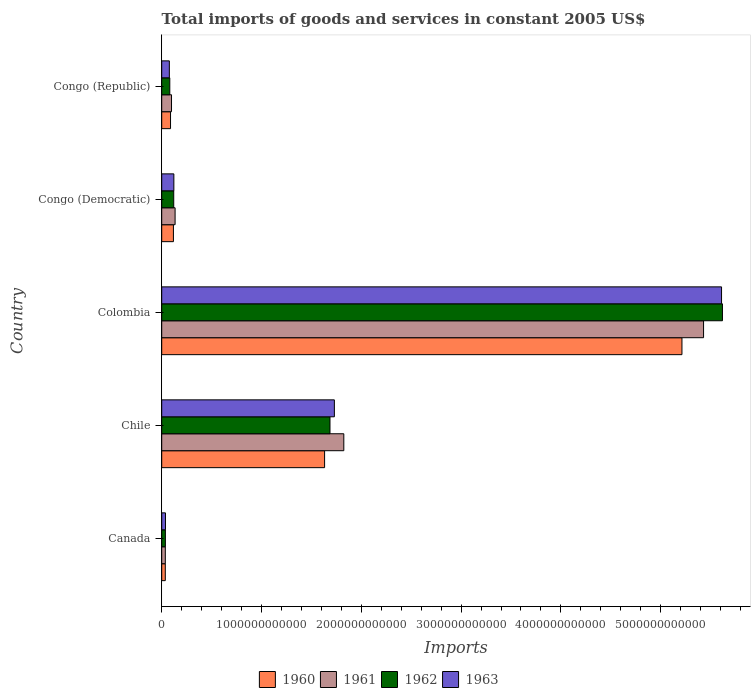How many groups of bars are there?
Keep it short and to the point. 5. How many bars are there on the 1st tick from the top?
Offer a terse response. 4. What is the label of the 4th group of bars from the top?
Keep it short and to the point. Chile. What is the total imports of goods and services in 1962 in Congo (Republic)?
Your answer should be compact. 8.10e+1. Across all countries, what is the maximum total imports of goods and services in 1963?
Provide a short and direct response. 5.61e+12. Across all countries, what is the minimum total imports of goods and services in 1962?
Give a very brief answer. 3.69e+1. In which country was the total imports of goods and services in 1963 minimum?
Ensure brevity in your answer.  Canada. What is the total total imports of goods and services in 1962 in the graph?
Offer a terse response. 7.54e+12. What is the difference between the total imports of goods and services in 1963 in Canada and that in Congo (Democratic)?
Provide a succinct answer. -8.39e+1. What is the difference between the total imports of goods and services in 1961 in Chile and the total imports of goods and services in 1962 in Congo (Republic)?
Provide a short and direct response. 1.74e+12. What is the average total imports of goods and services in 1963 per country?
Your response must be concise. 1.52e+12. What is the difference between the total imports of goods and services in 1961 and total imports of goods and services in 1963 in Congo (Republic)?
Offer a terse response. 2.18e+1. What is the ratio of the total imports of goods and services in 1962 in Colombia to that in Congo (Democratic)?
Ensure brevity in your answer.  46.63. Is the total imports of goods and services in 1963 in Canada less than that in Congo (Republic)?
Provide a succinct answer. Yes. What is the difference between the highest and the second highest total imports of goods and services in 1963?
Your answer should be very brief. 3.88e+12. What is the difference between the highest and the lowest total imports of goods and services in 1962?
Offer a terse response. 5.58e+12. What does the 4th bar from the top in Chile represents?
Your answer should be compact. 1960. What does the 4th bar from the bottom in Colombia represents?
Give a very brief answer. 1963. Is it the case that in every country, the sum of the total imports of goods and services in 1963 and total imports of goods and services in 1962 is greater than the total imports of goods and services in 1961?
Ensure brevity in your answer.  Yes. How many bars are there?
Provide a short and direct response. 20. What is the difference between two consecutive major ticks on the X-axis?
Offer a very short reply. 1.00e+12. Are the values on the major ticks of X-axis written in scientific E-notation?
Keep it short and to the point. No. Does the graph contain any zero values?
Offer a very short reply. No. Where does the legend appear in the graph?
Provide a succinct answer. Bottom center. What is the title of the graph?
Give a very brief answer. Total imports of goods and services in constant 2005 US$. What is the label or title of the X-axis?
Ensure brevity in your answer.  Imports. What is the label or title of the Y-axis?
Make the answer very short. Country. What is the Imports in 1960 in Canada?
Offer a very short reply. 3.60e+1. What is the Imports in 1961 in Canada?
Your response must be concise. 3.61e+1. What is the Imports in 1962 in Canada?
Your response must be concise. 3.69e+1. What is the Imports of 1963 in Canada?
Your response must be concise. 3.79e+1. What is the Imports of 1960 in Chile?
Offer a terse response. 1.63e+12. What is the Imports in 1961 in Chile?
Provide a short and direct response. 1.82e+12. What is the Imports in 1962 in Chile?
Keep it short and to the point. 1.69e+12. What is the Imports of 1963 in Chile?
Give a very brief answer. 1.73e+12. What is the Imports in 1960 in Colombia?
Your answer should be compact. 5.21e+12. What is the Imports in 1961 in Colombia?
Keep it short and to the point. 5.43e+12. What is the Imports in 1962 in Colombia?
Your answer should be compact. 5.62e+12. What is the Imports of 1963 in Colombia?
Keep it short and to the point. 5.61e+12. What is the Imports of 1960 in Congo (Democratic)?
Your answer should be very brief. 1.17e+11. What is the Imports in 1961 in Congo (Democratic)?
Your answer should be very brief. 1.34e+11. What is the Imports in 1962 in Congo (Democratic)?
Provide a succinct answer. 1.20e+11. What is the Imports in 1963 in Congo (Democratic)?
Offer a terse response. 1.22e+11. What is the Imports in 1960 in Congo (Republic)?
Make the answer very short. 8.83e+1. What is the Imports of 1961 in Congo (Republic)?
Provide a short and direct response. 9.83e+1. What is the Imports of 1962 in Congo (Republic)?
Your answer should be very brief. 8.10e+1. What is the Imports in 1963 in Congo (Republic)?
Offer a terse response. 7.65e+1. Across all countries, what is the maximum Imports of 1960?
Provide a succinct answer. 5.21e+12. Across all countries, what is the maximum Imports in 1961?
Offer a terse response. 5.43e+12. Across all countries, what is the maximum Imports in 1962?
Give a very brief answer. 5.62e+12. Across all countries, what is the maximum Imports of 1963?
Keep it short and to the point. 5.61e+12. Across all countries, what is the minimum Imports in 1960?
Keep it short and to the point. 3.60e+1. Across all countries, what is the minimum Imports in 1961?
Offer a very short reply. 3.61e+1. Across all countries, what is the minimum Imports in 1962?
Offer a terse response. 3.69e+1. Across all countries, what is the minimum Imports of 1963?
Provide a succinct answer. 3.79e+1. What is the total Imports of 1960 in the graph?
Make the answer very short. 7.09e+12. What is the total Imports in 1961 in the graph?
Provide a short and direct response. 7.52e+12. What is the total Imports in 1962 in the graph?
Make the answer very short. 7.54e+12. What is the total Imports in 1963 in the graph?
Keep it short and to the point. 7.58e+12. What is the difference between the Imports of 1960 in Canada and that in Chile?
Keep it short and to the point. -1.60e+12. What is the difference between the Imports in 1961 in Canada and that in Chile?
Give a very brief answer. -1.79e+12. What is the difference between the Imports of 1962 in Canada and that in Chile?
Offer a very short reply. -1.65e+12. What is the difference between the Imports in 1963 in Canada and that in Chile?
Provide a short and direct response. -1.69e+12. What is the difference between the Imports of 1960 in Canada and that in Colombia?
Give a very brief answer. -5.18e+12. What is the difference between the Imports of 1961 in Canada and that in Colombia?
Make the answer very short. -5.39e+12. What is the difference between the Imports of 1962 in Canada and that in Colombia?
Provide a short and direct response. -5.58e+12. What is the difference between the Imports of 1963 in Canada and that in Colombia?
Provide a short and direct response. -5.57e+12. What is the difference between the Imports in 1960 in Canada and that in Congo (Democratic)?
Provide a succinct answer. -8.14e+1. What is the difference between the Imports in 1961 in Canada and that in Congo (Democratic)?
Your answer should be very brief. -9.81e+1. What is the difference between the Imports of 1962 in Canada and that in Congo (Democratic)?
Offer a terse response. -8.36e+1. What is the difference between the Imports in 1963 in Canada and that in Congo (Democratic)?
Your response must be concise. -8.39e+1. What is the difference between the Imports in 1960 in Canada and that in Congo (Republic)?
Make the answer very short. -5.24e+1. What is the difference between the Imports in 1961 in Canada and that in Congo (Republic)?
Ensure brevity in your answer.  -6.22e+1. What is the difference between the Imports in 1962 in Canada and that in Congo (Republic)?
Give a very brief answer. -4.41e+1. What is the difference between the Imports in 1963 in Canada and that in Congo (Republic)?
Your answer should be compact. -3.86e+1. What is the difference between the Imports of 1960 in Chile and that in Colombia?
Ensure brevity in your answer.  -3.58e+12. What is the difference between the Imports of 1961 in Chile and that in Colombia?
Provide a succinct answer. -3.61e+12. What is the difference between the Imports in 1962 in Chile and that in Colombia?
Provide a short and direct response. -3.93e+12. What is the difference between the Imports in 1963 in Chile and that in Colombia?
Make the answer very short. -3.88e+12. What is the difference between the Imports in 1960 in Chile and that in Congo (Democratic)?
Your response must be concise. 1.51e+12. What is the difference between the Imports of 1961 in Chile and that in Congo (Democratic)?
Give a very brief answer. 1.69e+12. What is the difference between the Imports in 1962 in Chile and that in Congo (Democratic)?
Your response must be concise. 1.57e+12. What is the difference between the Imports in 1963 in Chile and that in Congo (Democratic)?
Offer a very short reply. 1.61e+12. What is the difference between the Imports of 1960 in Chile and that in Congo (Republic)?
Keep it short and to the point. 1.54e+12. What is the difference between the Imports of 1961 in Chile and that in Congo (Republic)?
Provide a short and direct response. 1.73e+12. What is the difference between the Imports in 1962 in Chile and that in Congo (Republic)?
Keep it short and to the point. 1.61e+12. What is the difference between the Imports of 1963 in Chile and that in Congo (Republic)?
Your response must be concise. 1.65e+12. What is the difference between the Imports in 1960 in Colombia and that in Congo (Democratic)?
Your answer should be compact. 5.10e+12. What is the difference between the Imports of 1961 in Colombia and that in Congo (Democratic)?
Provide a short and direct response. 5.30e+12. What is the difference between the Imports in 1962 in Colombia and that in Congo (Democratic)?
Keep it short and to the point. 5.50e+12. What is the difference between the Imports of 1963 in Colombia and that in Congo (Democratic)?
Ensure brevity in your answer.  5.49e+12. What is the difference between the Imports in 1960 in Colombia and that in Congo (Republic)?
Your answer should be compact. 5.13e+12. What is the difference between the Imports of 1961 in Colombia and that in Congo (Republic)?
Your answer should be compact. 5.33e+12. What is the difference between the Imports in 1962 in Colombia and that in Congo (Republic)?
Your response must be concise. 5.54e+12. What is the difference between the Imports of 1963 in Colombia and that in Congo (Republic)?
Provide a short and direct response. 5.53e+12. What is the difference between the Imports of 1960 in Congo (Democratic) and that in Congo (Republic)?
Give a very brief answer. 2.90e+1. What is the difference between the Imports in 1961 in Congo (Democratic) and that in Congo (Republic)?
Make the answer very short. 3.59e+1. What is the difference between the Imports of 1962 in Congo (Democratic) and that in Congo (Republic)?
Provide a succinct answer. 3.95e+1. What is the difference between the Imports in 1963 in Congo (Democratic) and that in Congo (Republic)?
Offer a very short reply. 4.53e+1. What is the difference between the Imports in 1960 in Canada and the Imports in 1961 in Chile?
Your answer should be very brief. -1.79e+12. What is the difference between the Imports of 1960 in Canada and the Imports of 1962 in Chile?
Your answer should be compact. -1.65e+12. What is the difference between the Imports of 1960 in Canada and the Imports of 1963 in Chile?
Provide a short and direct response. -1.69e+12. What is the difference between the Imports of 1961 in Canada and the Imports of 1962 in Chile?
Provide a short and direct response. -1.65e+12. What is the difference between the Imports in 1961 in Canada and the Imports in 1963 in Chile?
Ensure brevity in your answer.  -1.69e+12. What is the difference between the Imports of 1962 in Canada and the Imports of 1963 in Chile?
Offer a very short reply. -1.69e+12. What is the difference between the Imports in 1960 in Canada and the Imports in 1961 in Colombia?
Provide a succinct answer. -5.39e+12. What is the difference between the Imports of 1960 in Canada and the Imports of 1962 in Colombia?
Keep it short and to the point. -5.58e+12. What is the difference between the Imports in 1960 in Canada and the Imports in 1963 in Colombia?
Keep it short and to the point. -5.57e+12. What is the difference between the Imports in 1961 in Canada and the Imports in 1962 in Colombia?
Your response must be concise. -5.58e+12. What is the difference between the Imports in 1961 in Canada and the Imports in 1963 in Colombia?
Your answer should be compact. -5.57e+12. What is the difference between the Imports in 1962 in Canada and the Imports in 1963 in Colombia?
Your response must be concise. -5.57e+12. What is the difference between the Imports in 1960 in Canada and the Imports in 1961 in Congo (Democratic)?
Make the answer very short. -9.82e+1. What is the difference between the Imports in 1960 in Canada and the Imports in 1962 in Congo (Democratic)?
Ensure brevity in your answer.  -8.45e+1. What is the difference between the Imports in 1960 in Canada and the Imports in 1963 in Congo (Democratic)?
Keep it short and to the point. -8.58e+1. What is the difference between the Imports of 1961 in Canada and the Imports of 1962 in Congo (Democratic)?
Your answer should be very brief. -8.44e+1. What is the difference between the Imports in 1961 in Canada and the Imports in 1963 in Congo (Democratic)?
Offer a very short reply. -8.57e+1. What is the difference between the Imports of 1962 in Canada and the Imports of 1963 in Congo (Democratic)?
Offer a very short reply. -8.49e+1. What is the difference between the Imports of 1960 in Canada and the Imports of 1961 in Congo (Republic)?
Make the answer very short. -6.23e+1. What is the difference between the Imports in 1960 in Canada and the Imports in 1962 in Congo (Republic)?
Your answer should be very brief. -4.50e+1. What is the difference between the Imports in 1960 in Canada and the Imports in 1963 in Congo (Republic)?
Your answer should be compact. -4.05e+1. What is the difference between the Imports in 1961 in Canada and the Imports in 1962 in Congo (Republic)?
Your response must be concise. -4.49e+1. What is the difference between the Imports of 1961 in Canada and the Imports of 1963 in Congo (Republic)?
Your answer should be very brief. -4.04e+1. What is the difference between the Imports in 1962 in Canada and the Imports in 1963 in Congo (Republic)?
Provide a succinct answer. -3.96e+1. What is the difference between the Imports of 1960 in Chile and the Imports of 1961 in Colombia?
Ensure brevity in your answer.  -3.80e+12. What is the difference between the Imports in 1960 in Chile and the Imports in 1962 in Colombia?
Provide a succinct answer. -3.99e+12. What is the difference between the Imports of 1960 in Chile and the Imports of 1963 in Colombia?
Provide a short and direct response. -3.98e+12. What is the difference between the Imports in 1961 in Chile and the Imports in 1962 in Colombia?
Your response must be concise. -3.79e+12. What is the difference between the Imports of 1961 in Chile and the Imports of 1963 in Colombia?
Your answer should be compact. -3.79e+12. What is the difference between the Imports in 1962 in Chile and the Imports in 1963 in Colombia?
Ensure brevity in your answer.  -3.92e+12. What is the difference between the Imports of 1960 in Chile and the Imports of 1961 in Congo (Democratic)?
Keep it short and to the point. 1.50e+12. What is the difference between the Imports in 1960 in Chile and the Imports in 1962 in Congo (Democratic)?
Ensure brevity in your answer.  1.51e+12. What is the difference between the Imports in 1960 in Chile and the Imports in 1963 in Congo (Democratic)?
Offer a terse response. 1.51e+12. What is the difference between the Imports of 1961 in Chile and the Imports of 1962 in Congo (Democratic)?
Offer a very short reply. 1.70e+12. What is the difference between the Imports of 1961 in Chile and the Imports of 1963 in Congo (Democratic)?
Offer a very short reply. 1.70e+12. What is the difference between the Imports in 1962 in Chile and the Imports in 1963 in Congo (Democratic)?
Provide a succinct answer. 1.56e+12. What is the difference between the Imports in 1960 in Chile and the Imports in 1961 in Congo (Republic)?
Keep it short and to the point. 1.53e+12. What is the difference between the Imports in 1960 in Chile and the Imports in 1962 in Congo (Republic)?
Give a very brief answer. 1.55e+12. What is the difference between the Imports of 1960 in Chile and the Imports of 1963 in Congo (Republic)?
Your answer should be very brief. 1.56e+12. What is the difference between the Imports in 1961 in Chile and the Imports in 1962 in Congo (Republic)?
Your answer should be very brief. 1.74e+12. What is the difference between the Imports of 1961 in Chile and the Imports of 1963 in Congo (Republic)?
Keep it short and to the point. 1.75e+12. What is the difference between the Imports of 1962 in Chile and the Imports of 1963 in Congo (Republic)?
Offer a very short reply. 1.61e+12. What is the difference between the Imports in 1960 in Colombia and the Imports in 1961 in Congo (Democratic)?
Ensure brevity in your answer.  5.08e+12. What is the difference between the Imports in 1960 in Colombia and the Imports in 1962 in Congo (Democratic)?
Offer a very short reply. 5.09e+12. What is the difference between the Imports in 1960 in Colombia and the Imports in 1963 in Congo (Democratic)?
Offer a very short reply. 5.09e+12. What is the difference between the Imports of 1961 in Colombia and the Imports of 1962 in Congo (Democratic)?
Ensure brevity in your answer.  5.31e+12. What is the difference between the Imports of 1961 in Colombia and the Imports of 1963 in Congo (Democratic)?
Provide a short and direct response. 5.31e+12. What is the difference between the Imports of 1962 in Colombia and the Imports of 1963 in Congo (Democratic)?
Ensure brevity in your answer.  5.50e+12. What is the difference between the Imports of 1960 in Colombia and the Imports of 1961 in Congo (Republic)?
Give a very brief answer. 5.12e+12. What is the difference between the Imports of 1960 in Colombia and the Imports of 1962 in Congo (Republic)?
Offer a very short reply. 5.13e+12. What is the difference between the Imports in 1960 in Colombia and the Imports in 1963 in Congo (Republic)?
Make the answer very short. 5.14e+12. What is the difference between the Imports in 1961 in Colombia and the Imports in 1962 in Congo (Republic)?
Your answer should be compact. 5.35e+12. What is the difference between the Imports of 1961 in Colombia and the Imports of 1963 in Congo (Republic)?
Offer a terse response. 5.35e+12. What is the difference between the Imports of 1962 in Colombia and the Imports of 1963 in Congo (Republic)?
Provide a succinct answer. 5.54e+12. What is the difference between the Imports of 1960 in Congo (Democratic) and the Imports of 1961 in Congo (Republic)?
Ensure brevity in your answer.  1.91e+1. What is the difference between the Imports in 1960 in Congo (Democratic) and the Imports in 1962 in Congo (Republic)?
Your response must be concise. 3.64e+1. What is the difference between the Imports of 1960 in Congo (Democratic) and the Imports of 1963 in Congo (Republic)?
Ensure brevity in your answer.  4.09e+1. What is the difference between the Imports in 1961 in Congo (Democratic) and the Imports in 1962 in Congo (Republic)?
Provide a short and direct response. 5.32e+1. What is the difference between the Imports in 1961 in Congo (Democratic) and the Imports in 1963 in Congo (Republic)?
Ensure brevity in your answer.  5.77e+1. What is the difference between the Imports of 1962 in Congo (Democratic) and the Imports of 1963 in Congo (Republic)?
Provide a short and direct response. 4.40e+1. What is the average Imports in 1960 per country?
Keep it short and to the point. 1.42e+12. What is the average Imports of 1961 per country?
Your answer should be compact. 1.50e+12. What is the average Imports of 1962 per country?
Give a very brief answer. 1.51e+12. What is the average Imports in 1963 per country?
Your response must be concise. 1.52e+12. What is the difference between the Imports of 1960 and Imports of 1961 in Canada?
Keep it short and to the point. -9.09e+07. What is the difference between the Imports in 1960 and Imports in 1962 in Canada?
Keep it short and to the point. -9.27e+08. What is the difference between the Imports in 1960 and Imports in 1963 in Canada?
Your answer should be compact. -1.91e+09. What is the difference between the Imports in 1961 and Imports in 1962 in Canada?
Give a very brief answer. -8.37e+08. What is the difference between the Imports of 1961 and Imports of 1963 in Canada?
Provide a succinct answer. -1.82e+09. What is the difference between the Imports of 1962 and Imports of 1963 in Canada?
Make the answer very short. -9.82e+08. What is the difference between the Imports of 1960 and Imports of 1961 in Chile?
Offer a terse response. -1.93e+11. What is the difference between the Imports in 1960 and Imports in 1962 in Chile?
Make the answer very short. -5.42e+1. What is the difference between the Imports in 1960 and Imports in 1963 in Chile?
Offer a terse response. -9.81e+1. What is the difference between the Imports in 1961 and Imports in 1962 in Chile?
Give a very brief answer. 1.39e+11. What is the difference between the Imports in 1961 and Imports in 1963 in Chile?
Your answer should be compact. 9.46e+1. What is the difference between the Imports of 1962 and Imports of 1963 in Chile?
Make the answer very short. -4.39e+1. What is the difference between the Imports of 1960 and Imports of 1961 in Colombia?
Give a very brief answer. -2.17e+11. What is the difference between the Imports of 1960 and Imports of 1962 in Colombia?
Your answer should be compact. -4.06e+11. What is the difference between the Imports of 1960 and Imports of 1963 in Colombia?
Your answer should be compact. -3.97e+11. What is the difference between the Imports in 1961 and Imports in 1962 in Colombia?
Make the answer very short. -1.89e+11. What is the difference between the Imports of 1961 and Imports of 1963 in Colombia?
Ensure brevity in your answer.  -1.80e+11. What is the difference between the Imports of 1962 and Imports of 1963 in Colombia?
Offer a terse response. 9.11e+09. What is the difference between the Imports of 1960 and Imports of 1961 in Congo (Democratic)?
Offer a terse response. -1.68e+1. What is the difference between the Imports of 1960 and Imports of 1962 in Congo (Democratic)?
Keep it short and to the point. -3.13e+09. What is the difference between the Imports of 1960 and Imports of 1963 in Congo (Democratic)?
Provide a short and direct response. -4.41e+09. What is the difference between the Imports in 1961 and Imports in 1962 in Congo (Democratic)?
Provide a short and direct response. 1.37e+1. What is the difference between the Imports of 1961 and Imports of 1963 in Congo (Democratic)?
Keep it short and to the point. 1.24e+1. What is the difference between the Imports in 1962 and Imports in 1963 in Congo (Democratic)?
Your answer should be very brief. -1.28e+09. What is the difference between the Imports in 1960 and Imports in 1961 in Congo (Republic)?
Your answer should be very brief. -9.92e+09. What is the difference between the Imports of 1960 and Imports of 1962 in Congo (Republic)?
Give a very brief answer. 7.36e+09. What is the difference between the Imports in 1960 and Imports in 1963 in Congo (Republic)?
Provide a succinct answer. 1.18e+1. What is the difference between the Imports in 1961 and Imports in 1962 in Congo (Republic)?
Ensure brevity in your answer.  1.73e+1. What is the difference between the Imports in 1961 and Imports in 1963 in Congo (Republic)?
Make the answer very short. 2.18e+1. What is the difference between the Imports in 1962 and Imports in 1963 in Congo (Republic)?
Your answer should be compact. 4.48e+09. What is the ratio of the Imports in 1960 in Canada to that in Chile?
Your answer should be compact. 0.02. What is the ratio of the Imports in 1961 in Canada to that in Chile?
Provide a short and direct response. 0.02. What is the ratio of the Imports of 1962 in Canada to that in Chile?
Your answer should be very brief. 0.02. What is the ratio of the Imports of 1963 in Canada to that in Chile?
Give a very brief answer. 0.02. What is the ratio of the Imports in 1960 in Canada to that in Colombia?
Your answer should be compact. 0.01. What is the ratio of the Imports in 1961 in Canada to that in Colombia?
Your answer should be compact. 0.01. What is the ratio of the Imports in 1962 in Canada to that in Colombia?
Ensure brevity in your answer.  0.01. What is the ratio of the Imports in 1963 in Canada to that in Colombia?
Your answer should be compact. 0.01. What is the ratio of the Imports of 1960 in Canada to that in Congo (Democratic)?
Make the answer very short. 0.31. What is the ratio of the Imports of 1961 in Canada to that in Congo (Democratic)?
Ensure brevity in your answer.  0.27. What is the ratio of the Imports in 1962 in Canada to that in Congo (Democratic)?
Provide a short and direct response. 0.31. What is the ratio of the Imports of 1963 in Canada to that in Congo (Democratic)?
Offer a terse response. 0.31. What is the ratio of the Imports in 1960 in Canada to that in Congo (Republic)?
Offer a very short reply. 0.41. What is the ratio of the Imports in 1961 in Canada to that in Congo (Republic)?
Keep it short and to the point. 0.37. What is the ratio of the Imports of 1962 in Canada to that in Congo (Republic)?
Your answer should be compact. 0.46. What is the ratio of the Imports of 1963 in Canada to that in Congo (Republic)?
Provide a short and direct response. 0.5. What is the ratio of the Imports of 1960 in Chile to that in Colombia?
Provide a short and direct response. 0.31. What is the ratio of the Imports of 1961 in Chile to that in Colombia?
Make the answer very short. 0.34. What is the ratio of the Imports of 1962 in Chile to that in Colombia?
Offer a very short reply. 0.3. What is the ratio of the Imports in 1963 in Chile to that in Colombia?
Give a very brief answer. 0.31. What is the ratio of the Imports in 1960 in Chile to that in Congo (Democratic)?
Offer a very short reply. 13.91. What is the ratio of the Imports of 1961 in Chile to that in Congo (Democratic)?
Give a very brief answer. 13.6. What is the ratio of the Imports in 1962 in Chile to that in Congo (Democratic)?
Offer a terse response. 14. What is the ratio of the Imports in 1963 in Chile to that in Congo (Democratic)?
Your answer should be compact. 14.21. What is the ratio of the Imports in 1960 in Chile to that in Congo (Republic)?
Make the answer very short. 18.47. What is the ratio of the Imports in 1961 in Chile to that in Congo (Republic)?
Your answer should be very brief. 18.57. What is the ratio of the Imports of 1962 in Chile to that in Congo (Republic)?
Give a very brief answer. 20.82. What is the ratio of the Imports of 1963 in Chile to that in Congo (Republic)?
Keep it short and to the point. 22.62. What is the ratio of the Imports of 1960 in Colombia to that in Congo (Democratic)?
Provide a succinct answer. 44.42. What is the ratio of the Imports of 1961 in Colombia to that in Congo (Democratic)?
Offer a very short reply. 40.47. What is the ratio of the Imports in 1962 in Colombia to that in Congo (Democratic)?
Provide a short and direct response. 46.63. What is the ratio of the Imports of 1963 in Colombia to that in Congo (Democratic)?
Your answer should be very brief. 46.07. What is the ratio of the Imports in 1960 in Colombia to that in Congo (Republic)?
Your answer should be compact. 59.01. What is the ratio of the Imports in 1961 in Colombia to that in Congo (Republic)?
Offer a terse response. 55.26. What is the ratio of the Imports in 1962 in Colombia to that in Congo (Republic)?
Give a very brief answer. 69.39. What is the ratio of the Imports in 1963 in Colombia to that in Congo (Republic)?
Your response must be concise. 73.33. What is the ratio of the Imports of 1960 in Congo (Democratic) to that in Congo (Republic)?
Give a very brief answer. 1.33. What is the ratio of the Imports of 1961 in Congo (Democratic) to that in Congo (Republic)?
Provide a succinct answer. 1.37. What is the ratio of the Imports in 1962 in Congo (Democratic) to that in Congo (Republic)?
Offer a terse response. 1.49. What is the ratio of the Imports of 1963 in Congo (Democratic) to that in Congo (Republic)?
Your response must be concise. 1.59. What is the difference between the highest and the second highest Imports of 1960?
Offer a terse response. 3.58e+12. What is the difference between the highest and the second highest Imports of 1961?
Provide a short and direct response. 3.61e+12. What is the difference between the highest and the second highest Imports in 1962?
Offer a very short reply. 3.93e+12. What is the difference between the highest and the second highest Imports of 1963?
Your answer should be very brief. 3.88e+12. What is the difference between the highest and the lowest Imports in 1960?
Offer a terse response. 5.18e+12. What is the difference between the highest and the lowest Imports of 1961?
Offer a terse response. 5.39e+12. What is the difference between the highest and the lowest Imports in 1962?
Ensure brevity in your answer.  5.58e+12. What is the difference between the highest and the lowest Imports in 1963?
Offer a terse response. 5.57e+12. 